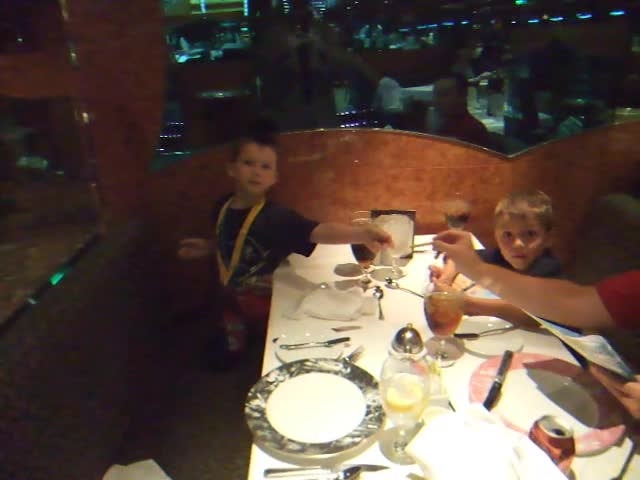Describe the objects in this image and their specific colors. I can see dining table in black, ivory, and tan tones, people in black, maroon, and brown tones, people in black, brown, and maroon tones, people in black, maroon, and brown tones, and wine glass in black, khaki, beige, and tan tones in this image. 